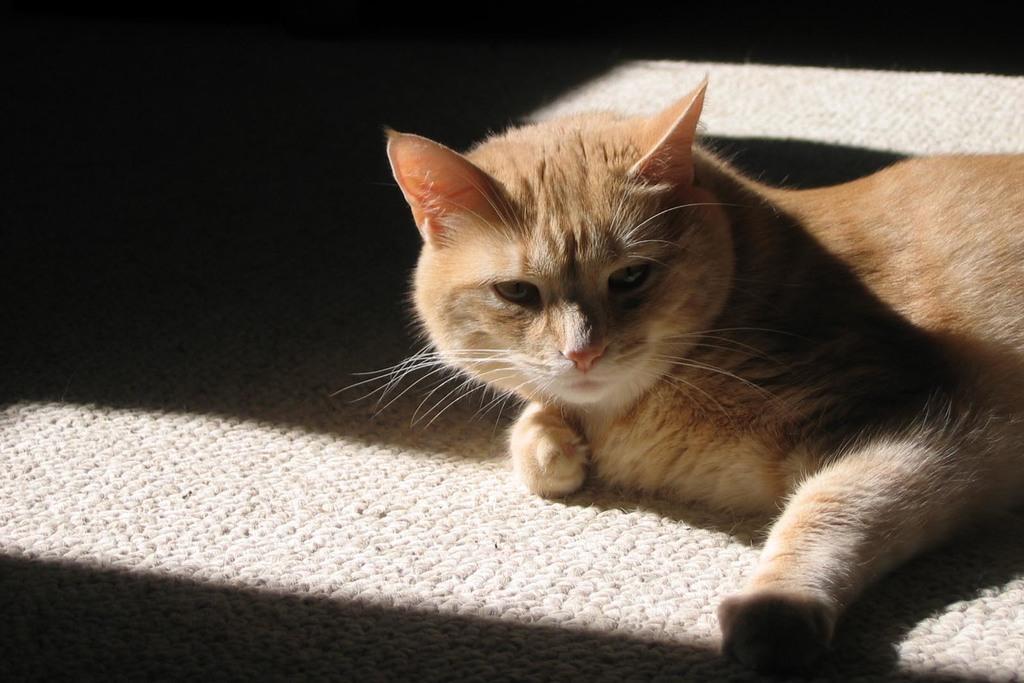Can you describe this image briefly? In this picture I can see there is a cat lying on the floor and it has brown fur and there is a carpet on the floor. 